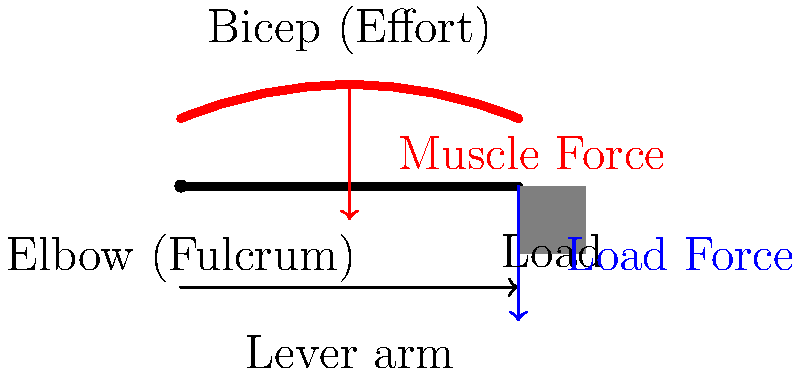As a retired civil engineer with expertise in home construction and safety, you're advising a client on proper lifting techniques to prevent injury during a radon mitigation system installation. Using the illustration of the human arm as a lever system, explain why it's crucial to keep heavy objects close to the body when lifting. How does the position of the load affect the force required by the bicep muscle? To understand why keeping heavy objects close to the body is important when lifting, let's analyze the arm as a lever system:

1. Identify the components:
   - Fulcrum: The elbow joint
   - Effort: The bicep muscle
   - Load: The weight being lifted

2. Understand the lever principle:
   The arm acts as a third-class lever, where the effort (bicep) is between the fulcrum (elbow) and the load.

3. Apply the law of moments:
   For equilibrium, the sum of moments about the fulcrum must be zero.
   $$(F_m \times d_m) = (F_l \times d_l)$$
   Where:
   $F_m$ = Force exerted by the muscle
   $d_m$ = Distance from muscle attachment to elbow
   $F_l$ = Force of the load
   $d_l$ = Distance from load to elbow

4. Analyze the effect of load position:
   - When the load is close to the body, $d_l$ is smaller.
   - When the load is far from the body, $d_l$ is larger.

5. Calculate the required muscle force:
   $$F_m = \frac{F_l \times d_l}{d_m}$$

6. Compare scenarios:
   - For a given load $F_l$, increasing $d_l$ will require a larger $F_m$.
   - Keeping the load close to the body minimizes $d_l$, thus reducing the required $F_m$.

7. Relate to safety:
   - Lower muscle force means less strain on the arm and back muscles.
   - Reduced strain decreases the risk of injury during lifting.

8. Apply to radon mitigation:
   When installing heavy components of a radon mitigation system, keeping them close to the body will significantly reduce the risk of musculoskeletal injuries.
Answer: Keeping loads close reduces the lever arm, decreasing required muscle force and injury risk. 